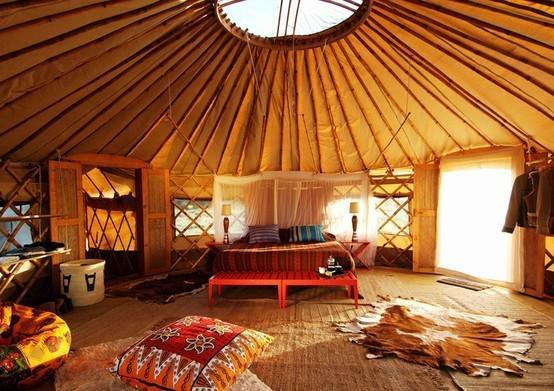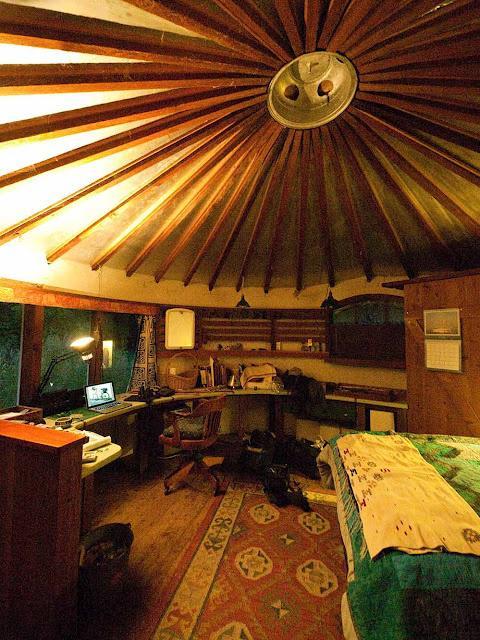The first image is the image on the left, the second image is the image on the right. Examine the images to the left and right. Is the description "In one image, an office area with an oak office chair on wheels and laptop computer is adjacent to the foot of a bed with an oriental rug on the floor." accurate? Answer yes or no. Yes. The first image is the image on the left, the second image is the image on the right. Examine the images to the left and right. Is the description "The lefthand image shows a yurt interior with an animal hide used in the bedroom decor." accurate? Answer yes or no. Yes. 